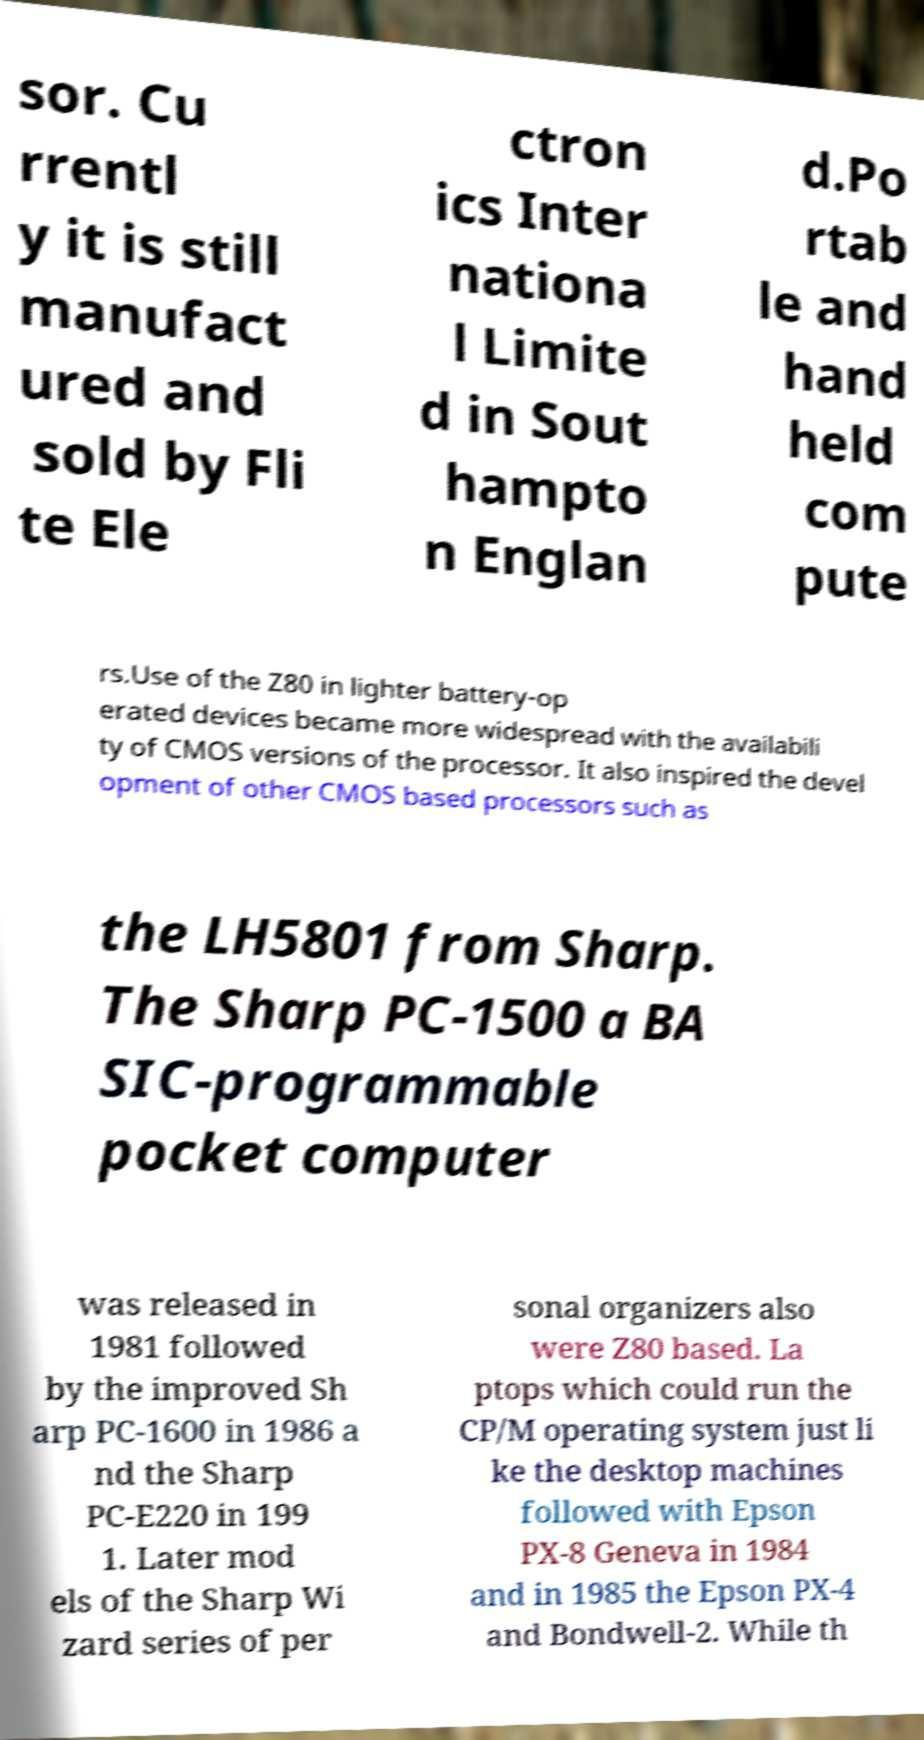Could you extract and type out the text from this image? sor. Cu rrentl y it is still manufact ured and sold by Fli te Ele ctron ics Inter nationa l Limite d in Sout hampto n Englan d.Po rtab le and hand held com pute rs.Use of the Z80 in lighter battery-op erated devices became more widespread with the availabili ty of CMOS versions of the processor. It also inspired the devel opment of other CMOS based processors such as the LH5801 from Sharp. The Sharp PC-1500 a BA SIC-programmable pocket computer was released in 1981 followed by the improved Sh arp PC-1600 in 1986 a nd the Sharp PC-E220 in 199 1. Later mod els of the Sharp Wi zard series of per sonal organizers also were Z80 based. La ptops which could run the CP/M operating system just li ke the desktop machines followed with Epson PX-8 Geneva in 1984 and in 1985 the Epson PX-4 and Bondwell-2. While th 